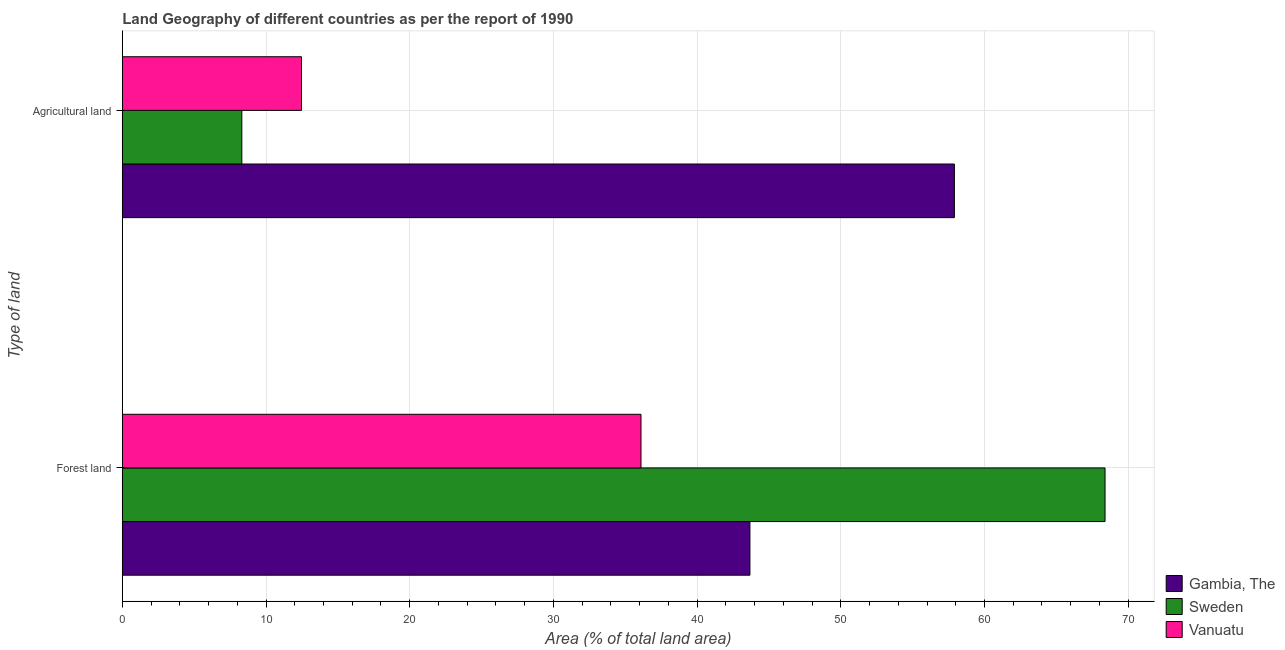How many different coloured bars are there?
Offer a very short reply. 3. Are the number of bars per tick equal to the number of legend labels?
Make the answer very short. Yes. What is the label of the 1st group of bars from the top?
Your answer should be compact. Agricultural land. What is the percentage of land area under agriculture in Sweden?
Offer a very short reply. 8.32. Across all countries, what is the maximum percentage of land area under agriculture?
Provide a short and direct response. 57.91. Across all countries, what is the minimum percentage of land area under forests?
Give a very brief answer. 36.1. In which country was the percentage of land area under agriculture maximum?
Make the answer very short. Gambia, The. In which country was the percentage of land area under agriculture minimum?
Provide a short and direct response. Sweden. What is the total percentage of land area under agriculture in the graph?
Your answer should be compact. 78.69. What is the difference between the percentage of land area under forests in Gambia, The and that in Vanuatu?
Offer a very short reply. 7.58. What is the difference between the percentage of land area under agriculture in Vanuatu and the percentage of land area under forests in Gambia, The?
Offer a terse response. -31.21. What is the average percentage of land area under forests per country?
Give a very brief answer. 49.39. What is the difference between the percentage of land area under agriculture and percentage of land area under forests in Vanuatu?
Give a very brief answer. -23.63. What is the ratio of the percentage of land area under agriculture in Gambia, The to that in Vanuatu?
Your response must be concise. 4.64. Is the percentage of land area under agriculture in Gambia, The less than that in Vanuatu?
Provide a succinct answer. No. In how many countries, is the percentage of land area under forests greater than the average percentage of land area under forests taken over all countries?
Offer a terse response. 1. What does the 1st bar from the top in Agricultural land represents?
Give a very brief answer. Vanuatu. Are all the bars in the graph horizontal?
Offer a terse response. Yes. How many countries are there in the graph?
Provide a short and direct response. 3. What is the difference between two consecutive major ticks on the X-axis?
Keep it short and to the point. 10. Are the values on the major ticks of X-axis written in scientific E-notation?
Provide a short and direct response. No. Does the graph contain any zero values?
Provide a succinct answer. No. Does the graph contain grids?
Give a very brief answer. Yes. How are the legend labels stacked?
Make the answer very short. Vertical. What is the title of the graph?
Your response must be concise. Land Geography of different countries as per the report of 1990. Does "Fragile and conflict affected situations" appear as one of the legend labels in the graph?
Your answer should be compact. No. What is the label or title of the X-axis?
Provide a succinct answer. Area (% of total land area). What is the label or title of the Y-axis?
Offer a terse response. Type of land. What is the Area (% of total land area) of Gambia, The in Forest land?
Your response must be concise. 43.68. What is the Area (% of total land area) in Sweden in Forest land?
Your answer should be compact. 68.39. What is the Area (% of total land area) of Vanuatu in Forest land?
Your answer should be compact. 36.1. What is the Area (% of total land area) of Gambia, The in Agricultural land?
Provide a short and direct response. 57.91. What is the Area (% of total land area) in Sweden in Agricultural land?
Ensure brevity in your answer.  8.32. What is the Area (% of total land area) in Vanuatu in Agricultural land?
Make the answer very short. 12.47. Across all Type of land, what is the maximum Area (% of total land area) in Gambia, The?
Keep it short and to the point. 57.91. Across all Type of land, what is the maximum Area (% of total land area) in Sweden?
Offer a terse response. 68.39. Across all Type of land, what is the maximum Area (% of total land area) of Vanuatu?
Your answer should be compact. 36.1. Across all Type of land, what is the minimum Area (% of total land area) in Gambia, The?
Your answer should be compact. 43.68. Across all Type of land, what is the minimum Area (% of total land area) of Sweden?
Keep it short and to the point. 8.32. Across all Type of land, what is the minimum Area (% of total land area) of Vanuatu?
Give a very brief answer. 12.47. What is the total Area (% of total land area) of Gambia, The in the graph?
Give a very brief answer. 101.58. What is the total Area (% of total land area) of Sweden in the graph?
Offer a terse response. 76.71. What is the total Area (% of total land area) of Vanuatu in the graph?
Provide a short and direct response. 48.56. What is the difference between the Area (% of total land area) of Gambia, The in Forest land and that in Agricultural land?
Ensure brevity in your answer.  -14.23. What is the difference between the Area (% of total land area) in Sweden in Forest land and that in Agricultural land?
Your answer should be compact. 60.07. What is the difference between the Area (% of total land area) in Vanuatu in Forest land and that in Agricultural land?
Offer a very short reply. 23.63. What is the difference between the Area (% of total land area) of Gambia, The in Forest land and the Area (% of total land area) of Sweden in Agricultural land?
Provide a short and direct response. 35.36. What is the difference between the Area (% of total land area) of Gambia, The in Forest land and the Area (% of total land area) of Vanuatu in Agricultural land?
Your response must be concise. 31.21. What is the difference between the Area (% of total land area) of Sweden in Forest land and the Area (% of total land area) of Vanuatu in Agricultural land?
Ensure brevity in your answer.  55.92. What is the average Area (% of total land area) of Gambia, The per Type of land?
Your answer should be compact. 50.79. What is the average Area (% of total land area) of Sweden per Type of land?
Offer a terse response. 38.35. What is the average Area (% of total land area) in Vanuatu per Type of land?
Offer a terse response. 24.28. What is the difference between the Area (% of total land area) of Gambia, The and Area (% of total land area) of Sweden in Forest land?
Offer a very short reply. -24.71. What is the difference between the Area (% of total land area) of Gambia, The and Area (% of total land area) of Vanuatu in Forest land?
Provide a short and direct response. 7.58. What is the difference between the Area (% of total land area) in Sweden and Area (% of total land area) in Vanuatu in Forest land?
Your answer should be compact. 32.29. What is the difference between the Area (% of total land area) in Gambia, The and Area (% of total land area) in Sweden in Agricultural land?
Keep it short and to the point. 49.59. What is the difference between the Area (% of total land area) of Gambia, The and Area (% of total land area) of Vanuatu in Agricultural land?
Make the answer very short. 45.44. What is the difference between the Area (% of total land area) in Sweden and Area (% of total land area) in Vanuatu in Agricultural land?
Your response must be concise. -4.15. What is the ratio of the Area (% of total land area) of Gambia, The in Forest land to that in Agricultural land?
Give a very brief answer. 0.75. What is the ratio of the Area (% of total land area) of Sweden in Forest land to that in Agricultural land?
Keep it short and to the point. 8.22. What is the ratio of the Area (% of total land area) of Vanuatu in Forest land to that in Agricultural land?
Your answer should be compact. 2.89. What is the difference between the highest and the second highest Area (% of total land area) of Gambia, The?
Provide a short and direct response. 14.23. What is the difference between the highest and the second highest Area (% of total land area) of Sweden?
Keep it short and to the point. 60.07. What is the difference between the highest and the second highest Area (% of total land area) in Vanuatu?
Keep it short and to the point. 23.63. What is the difference between the highest and the lowest Area (% of total land area) of Gambia, The?
Your answer should be compact. 14.23. What is the difference between the highest and the lowest Area (% of total land area) in Sweden?
Your answer should be compact. 60.07. What is the difference between the highest and the lowest Area (% of total land area) of Vanuatu?
Your response must be concise. 23.63. 